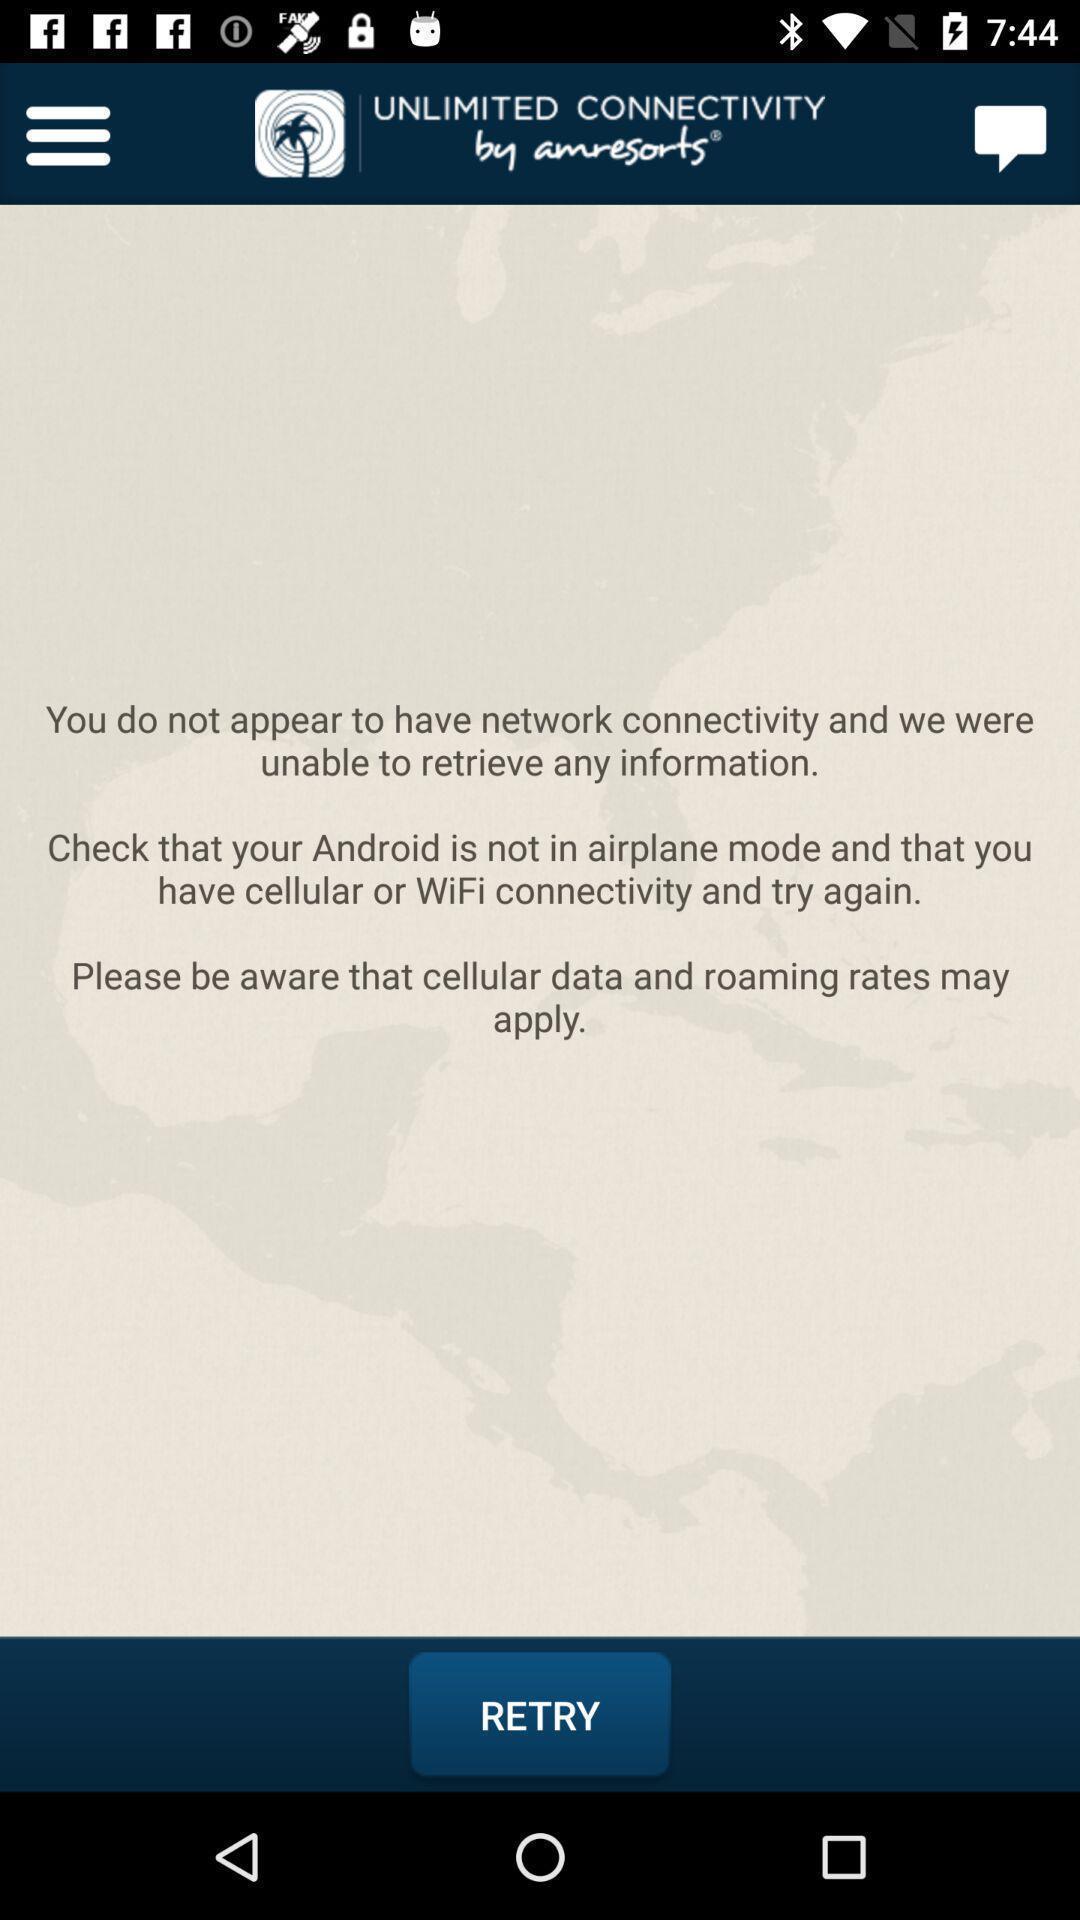What can you discern from this picture? Screen display network connectivity details. 